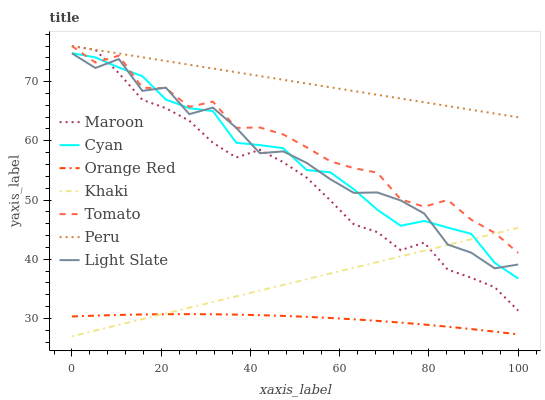Does Orange Red have the minimum area under the curve?
Answer yes or no. Yes. Does Peru have the maximum area under the curve?
Answer yes or no. Yes. Does Khaki have the minimum area under the curve?
Answer yes or no. No. Does Khaki have the maximum area under the curve?
Answer yes or no. No. Is Khaki the smoothest?
Answer yes or no. Yes. Is Light Slate the roughest?
Answer yes or no. Yes. Is Light Slate the smoothest?
Answer yes or no. No. Is Khaki the roughest?
Answer yes or no. No. Does Light Slate have the lowest value?
Answer yes or no. No. Does Peru have the highest value?
Answer yes or no. Yes. Does Khaki have the highest value?
Answer yes or no. No. Is Orange Red less than Light Slate?
Answer yes or no. Yes. Is Light Slate greater than Orange Red?
Answer yes or no. Yes. Does Maroon intersect Light Slate?
Answer yes or no. Yes. Is Maroon less than Light Slate?
Answer yes or no. No. Is Maroon greater than Light Slate?
Answer yes or no. No. Does Orange Red intersect Light Slate?
Answer yes or no. No. 